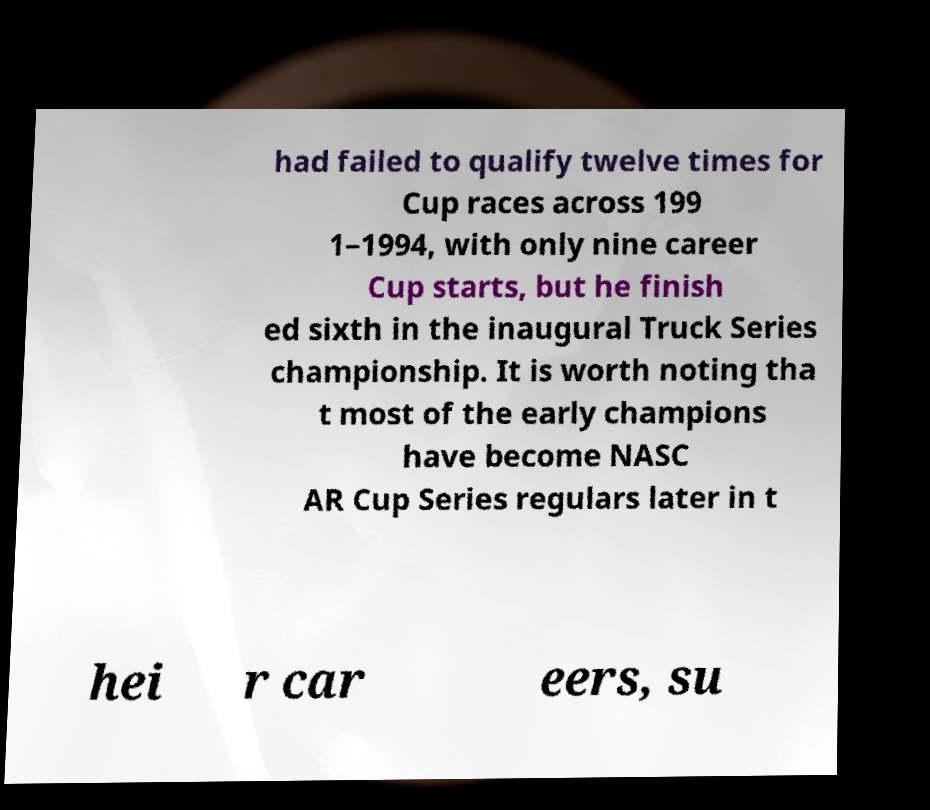There's text embedded in this image that I need extracted. Can you transcribe it verbatim? had failed to qualify twelve times for Cup races across 199 1–1994, with only nine career Cup starts, but he finish ed sixth in the inaugural Truck Series championship. It is worth noting tha t most of the early champions have become NASC AR Cup Series regulars later in t hei r car eers, su 